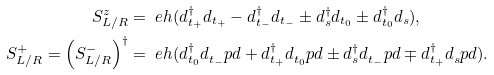Convert formula to latex. <formula><loc_0><loc_0><loc_500><loc_500>S _ { L / R } ^ { z } & = \ e h ( d _ { t _ { + } } ^ { \dag } d _ { t _ { + } } - d _ { t _ { - } } ^ { \dag } d _ { t _ { - } } \pm d _ { s } ^ { \dag } d _ { t _ { 0 } } \pm d _ { t _ { 0 } } ^ { \dag } d _ { s } ) , \\ S _ { L / R } ^ { + } = \left ( S _ { L / R } ^ { - } \right ) ^ { \dag } & = \ e h ( d _ { t _ { 0 } } ^ { \dag } d _ { t _ { - } } ^ { \ } p d + d _ { t _ { + } } ^ { \dag } d _ { t _ { 0 } } ^ { \ } p d \pm d _ { s } ^ { \dag } d _ { t _ { - } } ^ { \ } p d \mp d _ { t _ { + } } ^ { \dag } d _ { s } ^ { \ } p d ) .</formula> 